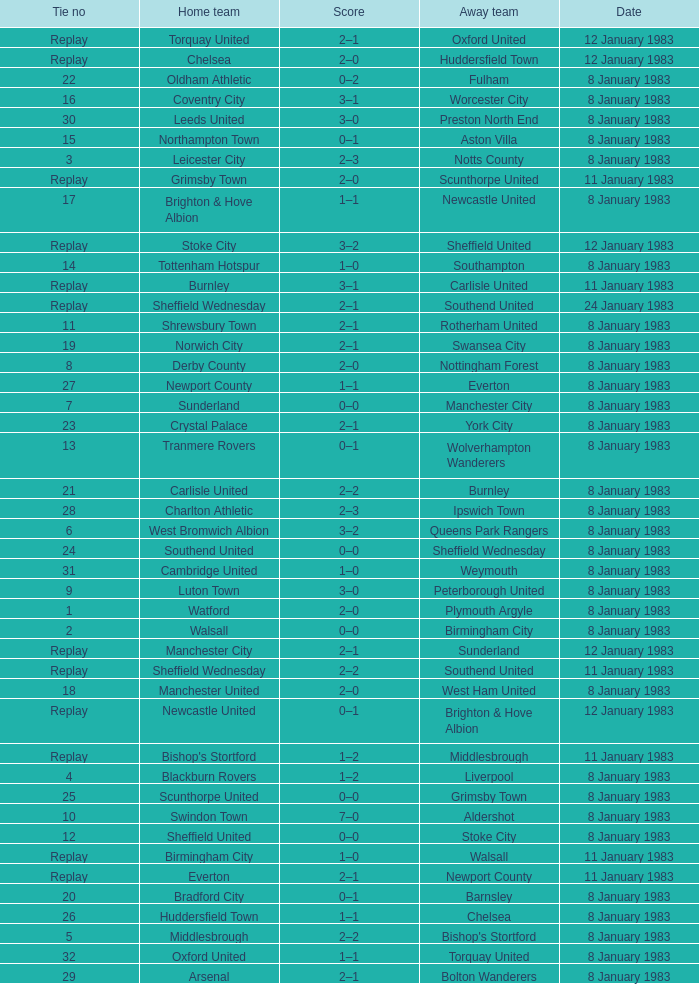For which tie was Scunthorpe United the away team? Replay. 